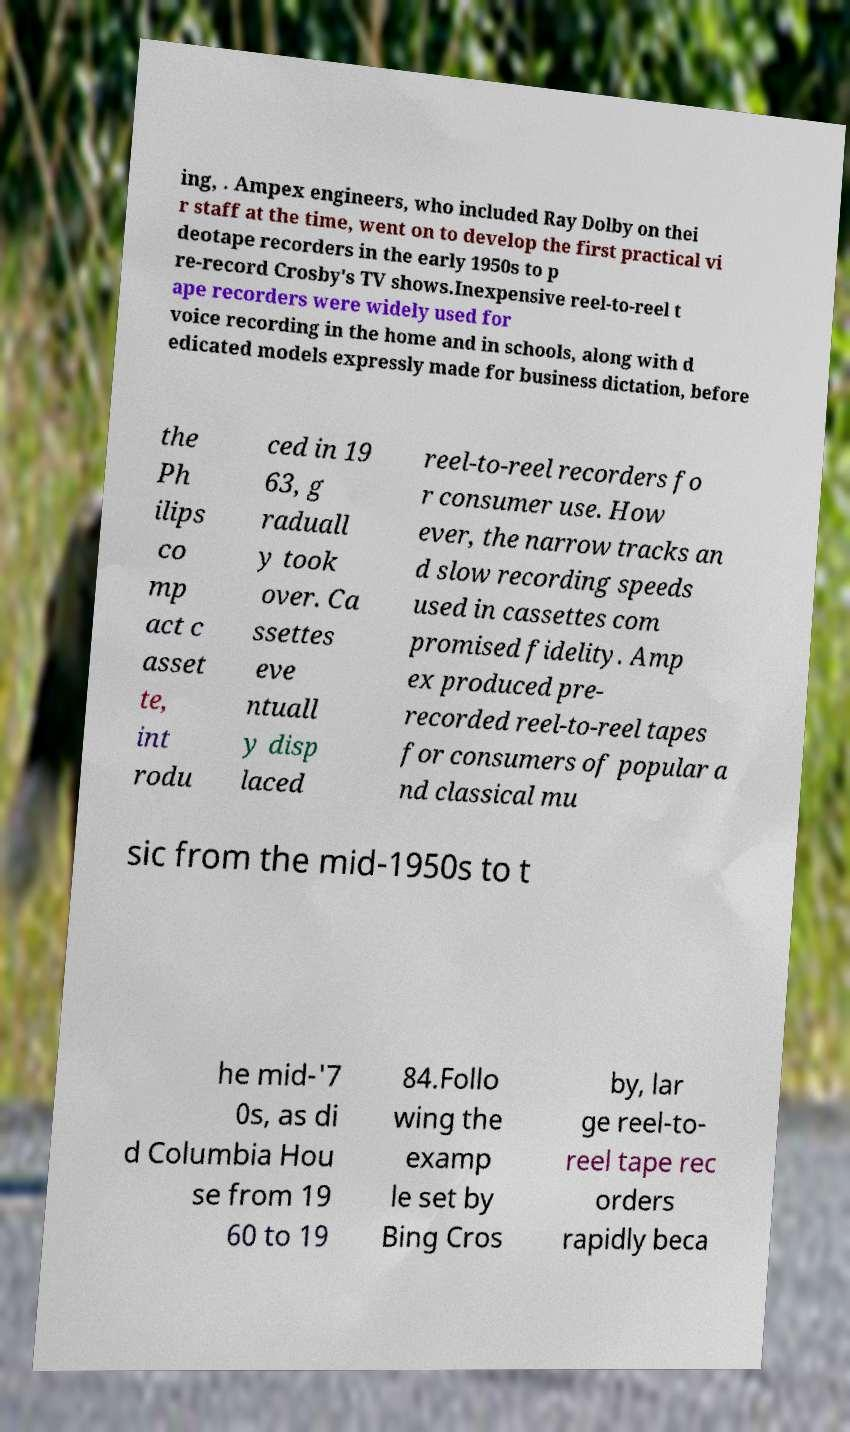Please identify and transcribe the text found in this image. ing, . Ampex engineers, who included Ray Dolby on thei r staff at the time, went on to develop the first practical vi deotape recorders in the early 1950s to p re-record Crosby's TV shows.Inexpensive reel-to-reel t ape recorders were widely used for voice recording in the home and in schools, along with d edicated models expressly made for business dictation, before the Ph ilips co mp act c asset te, int rodu ced in 19 63, g raduall y took over. Ca ssettes eve ntuall y disp laced reel-to-reel recorders fo r consumer use. How ever, the narrow tracks an d slow recording speeds used in cassettes com promised fidelity. Amp ex produced pre- recorded reel-to-reel tapes for consumers of popular a nd classical mu sic from the mid-1950s to t he mid-'7 0s, as di d Columbia Hou se from 19 60 to 19 84.Follo wing the examp le set by Bing Cros by, lar ge reel-to- reel tape rec orders rapidly beca 